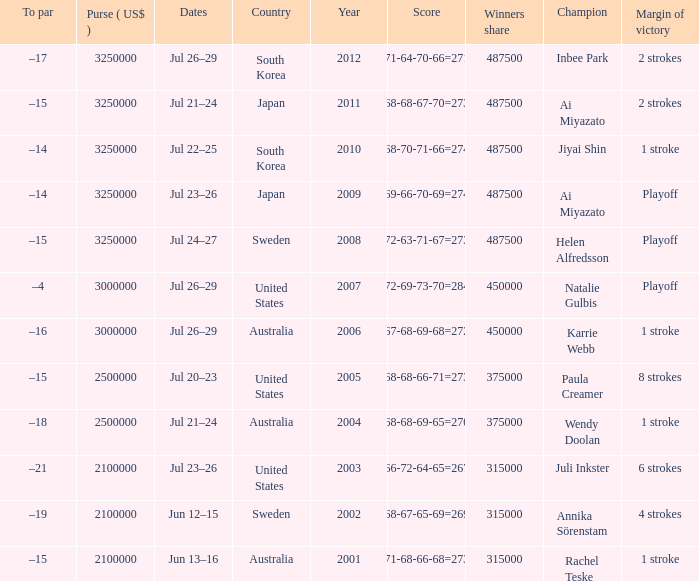Parse the table in full. {'header': ['To par', 'Purse ( US$ )', 'Dates', 'Country', 'Year', 'Score', 'Winners share', 'Champion', 'Margin of victory'], 'rows': [['–17', '3250000', 'Jul 26–29', 'South Korea', '2012', '71-64-70-66=271', '487500', 'Inbee Park', '2 strokes'], ['–15', '3250000', 'Jul 21–24', 'Japan', '2011', '68-68-67-70=273', '487500', 'Ai Miyazato', '2 strokes'], ['–14', '3250000', 'Jul 22–25', 'South Korea', '2010', '68-70-71-66=274', '487500', 'Jiyai Shin', '1 stroke'], ['–14', '3250000', 'Jul 23–26', 'Japan', '2009', '69-66-70-69=274', '487500', 'Ai Miyazato', 'Playoff'], ['–15', '3250000', 'Jul 24–27', 'Sweden', '2008', '72-63-71-67=273', '487500', 'Helen Alfredsson', 'Playoff'], ['–4', '3000000', 'Jul 26–29', 'United States', '2007', '72-69-73-70=284', '450000', 'Natalie Gulbis', 'Playoff'], ['–16', '3000000', 'Jul 26–29', 'Australia', '2006', '67-68-69-68=272', '450000', 'Karrie Webb', '1 stroke'], ['–15', '2500000', 'Jul 20–23', 'United States', '2005', '68-68-66-71=273', '375000', 'Paula Creamer', '8 strokes'], ['–18', '2500000', 'Jul 21–24', 'Australia', '2004', '68-68-69-65=270', '375000', 'Wendy Doolan', '1 stroke'], ['–21', '2100000', 'Jul 23–26', 'United States', '2003', '66-72-64-65=267', '315000', 'Juli Inkster', '6 strokes'], ['–19', '2100000', 'Jun 12–15', 'Sweden', '2002', '68-67-65-69=269', '315000', 'Annika Sörenstam', '4 strokes'], ['–15', '2100000', 'Jun 13–16', 'Australia', '2001', '71-68-66-68=273', '315000', 'Rachel Teske', '1 stroke']]} What countries have a margin of victory at 6 strokes? United States. 